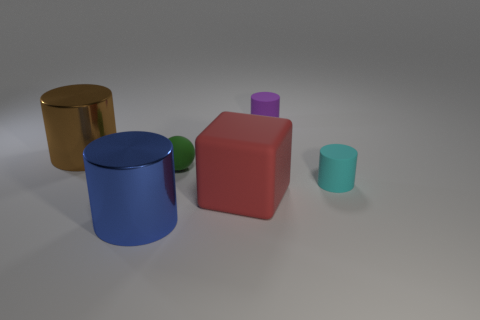There is a large metallic thing on the right side of the brown metallic object; what color is it?
Ensure brevity in your answer.  Blue. There is another small matte thing that is the same shape as the small cyan object; what color is it?
Offer a very short reply. Purple. How many small green objects are behind the cylinder that is behind the shiny thing behind the red rubber object?
Keep it short and to the point. 0. Is there anything else that is the same material as the small purple thing?
Provide a short and direct response. Yes. Is the number of large red cubes that are in front of the red thing less than the number of tiny green matte objects?
Your answer should be compact. Yes. Is the color of the block the same as the small sphere?
Offer a very short reply. No. What is the size of the cyan rubber object that is the same shape as the brown metallic thing?
Your response must be concise. Small. What number of cyan cylinders are made of the same material as the purple cylinder?
Make the answer very short. 1. Is the material of the thing behind the large brown cylinder the same as the tiny ball?
Offer a terse response. Yes. Is the number of large shiny cylinders to the right of the large matte block the same as the number of big gray things?
Provide a succinct answer. Yes. 